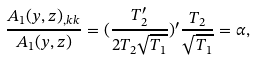<formula> <loc_0><loc_0><loc_500><loc_500>\frac { A _ { 1 } ( y , z ) _ { , k k } } { A _ { 1 } ( y , z ) } = ( \frac { T ^ { \prime } _ { 2 } } { 2 T _ { 2 } \sqrt { T _ { 1 } } } ) ^ { \prime } \frac { T _ { 2 } } { \sqrt { T _ { 1 } } } = \alpha ,</formula> 